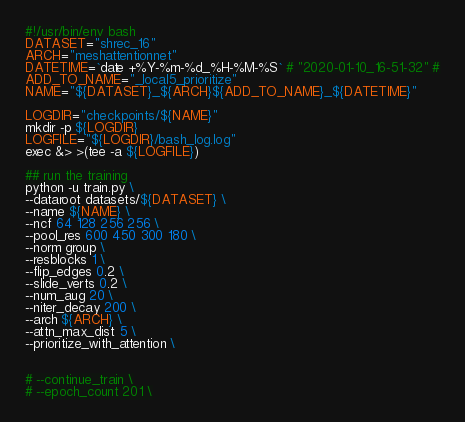Convert code to text. <code><loc_0><loc_0><loc_500><loc_500><_Bash_>#!/usr/bin/env bash
DATASET="shrec_16"
ARCH="meshattentionnet"
DATETIME=`date +%Y-%m-%d_%H-%M-%S` # "2020-01-10_16-51-32" #
ADD_TO_NAME="_local5_prioritize"
NAME="${DATASET}_${ARCH}${ADD_TO_NAME}_${DATETIME}"

LOGDIR="checkpoints/${NAME}"
mkdir -p ${LOGDIR}
LOGFILE="${LOGDIR}/bash_log.log"
exec &> >(tee -a ${LOGFILE})

## run the training
python -u train.py \
--dataroot datasets/${DATASET} \
--name ${NAME} \
--ncf 64 128 256 256 \
--pool_res 600 450 300 180 \
--norm group \
--resblocks 1 \
--flip_edges 0.2 \
--slide_verts 0.2 \
--num_aug 20 \
--niter_decay 200 \
--arch ${ARCH} \
--attn_max_dist 5 \
--prioritize_with_attention \


# --continue_train \
# --epoch_count 201 \
</code> 